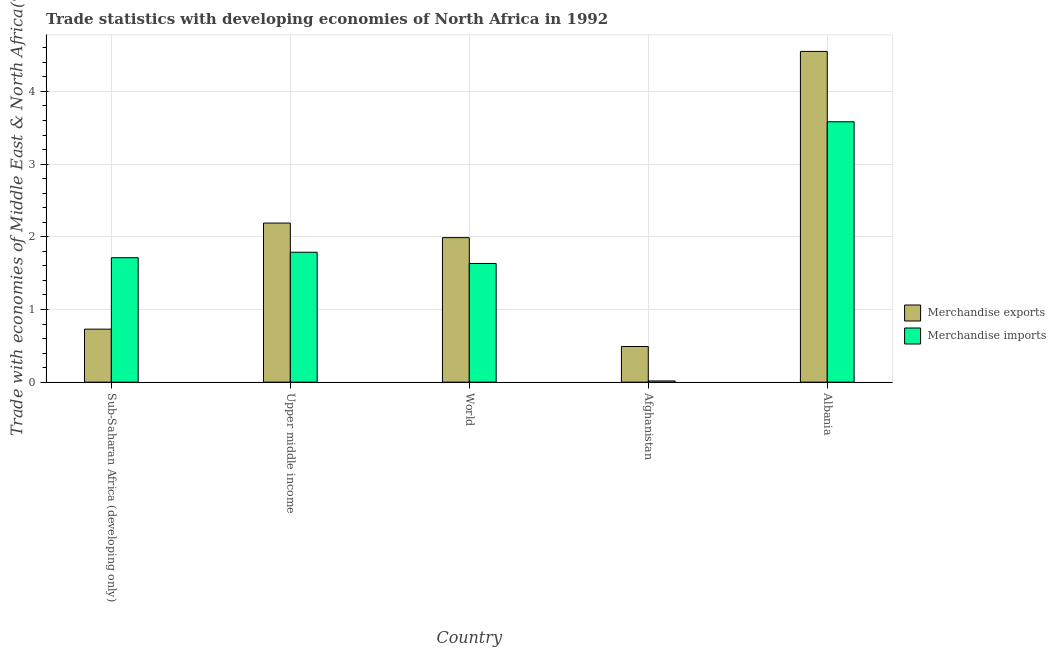How many different coloured bars are there?
Keep it short and to the point. 2. Are the number of bars on each tick of the X-axis equal?
Offer a terse response. Yes. How many bars are there on the 4th tick from the right?
Keep it short and to the point. 2. What is the label of the 4th group of bars from the left?
Offer a terse response. Afghanistan. In how many cases, is the number of bars for a given country not equal to the number of legend labels?
Offer a terse response. 0. What is the merchandise imports in Upper middle income?
Your answer should be compact. 1.79. Across all countries, what is the maximum merchandise imports?
Make the answer very short. 3.58. Across all countries, what is the minimum merchandise imports?
Provide a succinct answer. 0.02. In which country was the merchandise imports maximum?
Your answer should be very brief. Albania. In which country was the merchandise imports minimum?
Provide a short and direct response. Afghanistan. What is the total merchandise exports in the graph?
Your response must be concise. 9.95. What is the difference between the merchandise exports in Sub-Saharan Africa (developing only) and that in World?
Keep it short and to the point. -1.26. What is the difference between the merchandise exports in Afghanistan and the merchandise imports in World?
Give a very brief answer. -1.14. What is the average merchandise exports per country?
Offer a terse response. 1.99. What is the difference between the merchandise imports and merchandise exports in Sub-Saharan Africa (developing only)?
Offer a terse response. 0.98. In how many countries, is the merchandise imports greater than 4.4 %?
Ensure brevity in your answer.  0. What is the ratio of the merchandise imports in Albania to that in Sub-Saharan Africa (developing only)?
Your answer should be very brief. 2.09. Is the merchandise imports in Albania less than that in World?
Offer a very short reply. No. Is the difference between the merchandise exports in Albania and Upper middle income greater than the difference between the merchandise imports in Albania and Upper middle income?
Ensure brevity in your answer.  Yes. What is the difference between the highest and the second highest merchandise imports?
Offer a terse response. 1.8. What is the difference between the highest and the lowest merchandise exports?
Your answer should be compact. 4.06. Is the sum of the merchandise imports in Afghanistan and World greater than the maximum merchandise exports across all countries?
Provide a succinct answer. No. What does the 1st bar from the left in World represents?
Ensure brevity in your answer.  Merchandise exports. Are all the bars in the graph horizontal?
Keep it short and to the point. No. Does the graph contain any zero values?
Give a very brief answer. No. Where does the legend appear in the graph?
Offer a very short reply. Center right. How are the legend labels stacked?
Give a very brief answer. Vertical. What is the title of the graph?
Provide a succinct answer. Trade statistics with developing economies of North Africa in 1992. Does "Number of departures" appear as one of the legend labels in the graph?
Ensure brevity in your answer.  No. What is the label or title of the X-axis?
Your answer should be compact. Country. What is the label or title of the Y-axis?
Your answer should be compact. Trade with economies of Middle East & North Africa(%). What is the Trade with economies of Middle East & North Africa(%) in Merchandise exports in Sub-Saharan Africa (developing only)?
Ensure brevity in your answer.  0.73. What is the Trade with economies of Middle East & North Africa(%) of Merchandise imports in Sub-Saharan Africa (developing only)?
Offer a very short reply. 1.71. What is the Trade with economies of Middle East & North Africa(%) in Merchandise exports in Upper middle income?
Keep it short and to the point. 2.19. What is the Trade with economies of Middle East & North Africa(%) in Merchandise imports in Upper middle income?
Keep it short and to the point. 1.79. What is the Trade with economies of Middle East & North Africa(%) in Merchandise exports in World?
Provide a succinct answer. 1.99. What is the Trade with economies of Middle East & North Africa(%) in Merchandise imports in World?
Your answer should be very brief. 1.63. What is the Trade with economies of Middle East & North Africa(%) in Merchandise exports in Afghanistan?
Give a very brief answer. 0.49. What is the Trade with economies of Middle East & North Africa(%) in Merchandise imports in Afghanistan?
Your response must be concise. 0.02. What is the Trade with economies of Middle East & North Africa(%) of Merchandise exports in Albania?
Make the answer very short. 4.55. What is the Trade with economies of Middle East & North Africa(%) in Merchandise imports in Albania?
Keep it short and to the point. 3.58. Across all countries, what is the maximum Trade with economies of Middle East & North Africa(%) in Merchandise exports?
Your answer should be compact. 4.55. Across all countries, what is the maximum Trade with economies of Middle East & North Africa(%) of Merchandise imports?
Offer a terse response. 3.58. Across all countries, what is the minimum Trade with economies of Middle East & North Africa(%) of Merchandise exports?
Make the answer very short. 0.49. Across all countries, what is the minimum Trade with economies of Middle East & North Africa(%) of Merchandise imports?
Provide a succinct answer. 0.02. What is the total Trade with economies of Middle East & North Africa(%) of Merchandise exports in the graph?
Provide a short and direct response. 9.95. What is the total Trade with economies of Middle East & North Africa(%) in Merchandise imports in the graph?
Your response must be concise. 8.73. What is the difference between the Trade with economies of Middle East & North Africa(%) in Merchandise exports in Sub-Saharan Africa (developing only) and that in Upper middle income?
Your response must be concise. -1.46. What is the difference between the Trade with economies of Middle East & North Africa(%) in Merchandise imports in Sub-Saharan Africa (developing only) and that in Upper middle income?
Provide a succinct answer. -0.08. What is the difference between the Trade with economies of Middle East & North Africa(%) in Merchandise exports in Sub-Saharan Africa (developing only) and that in World?
Offer a terse response. -1.26. What is the difference between the Trade with economies of Middle East & North Africa(%) in Merchandise imports in Sub-Saharan Africa (developing only) and that in World?
Ensure brevity in your answer.  0.08. What is the difference between the Trade with economies of Middle East & North Africa(%) in Merchandise exports in Sub-Saharan Africa (developing only) and that in Afghanistan?
Offer a very short reply. 0.24. What is the difference between the Trade with economies of Middle East & North Africa(%) of Merchandise imports in Sub-Saharan Africa (developing only) and that in Afghanistan?
Offer a very short reply. 1.7. What is the difference between the Trade with economies of Middle East & North Africa(%) in Merchandise exports in Sub-Saharan Africa (developing only) and that in Albania?
Give a very brief answer. -3.82. What is the difference between the Trade with economies of Middle East & North Africa(%) of Merchandise imports in Sub-Saharan Africa (developing only) and that in Albania?
Offer a terse response. -1.87. What is the difference between the Trade with economies of Middle East & North Africa(%) in Merchandise exports in Upper middle income and that in World?
Your response must be concise. 0.2. What is the difference between the Trade with economies of Middle East & North Africa(%) of Merchandise imports in Upper middle income and that in World?
Offer a very short reply. 0.15. What is the difference between the Trade with economies of Middle East & North Africa(%) in Merchandise exports in Upper middle income and that in Afghanistan?
Offer a terse response. 1.7. What is the difference between the Trade with economies of Middle East & North Africa(%) in Merchandise imports in Upper middle income and that in Afghanistan?
Provide a succinct answer. 1.77. What is the difference between the Trade with economies of Middle East & North Africa(%) in Merchandise exports in Upper middle income and that in Albania?
Offer a terse response. -2.36. What is the difference between the Trade with economies of Middle East & North Africa(%) in Merchandise imports in Upper middle income and that in Albania?
Make the answer very short. -1.8. What is the difference between the Trade with economies of Middle East & North Africa(%) in Merchandise exports in World and that in Afghanistan?
Ensure brevity in your answer.  1.5. What is the difference between the Trade with economies of Middle East & North Africa(%) of Merchandise imports in World and that in Afghanistan?
Provide a short and direct response. 1.62. What is the difference between the Trade with economies of Middle East & North Africa(%) in Merchandise exports in World and that in Albania?
Provide a succinct answer. -2.56. What is the difference between the Trade with economies of Middle East & North Africa(%) of Merchandise imports in World and that in Albania?
Give a very brief answer. -1.95. What is the difference between the Trade with economies of Middle East & North Africa(%) of Merchandise exports in Afghanistan and that in Albania?
Offer a terse response. -4.06. What is the difference between the Trade with economies of Middle East & North Africa(%) in Merchandise imports in Afghanistan and that in Albania?
Keep it short and to the point. -3.57. What is the difference between the Trade with economies of Middle East & North Africa(%) of Merchandise exports in Sub-Saharan Africa (developing only) and the Trade with economies of Middle East & North Africa(%) of Merchandise imports in Upper middle income?
Your answer should be very brief. -1.06. What is the difference between the Trade with economies of Middle East & North Africa(%) in Merchandise exports in Sub-Saharan Africa (developing only) and the Trade with economies of Middle East & North Africa(%) in Merchandise imports in World?
Your response must be concise. -0.9. What is the difference between the Trade with economies of Middle East & North Africa(%) in Merchandise exports in Sub-Saharan Africa (developing only) and the Trade with economies of Middle East & North Africa(%) in Merchandise imports in Afghanistan?
Provide a short and direct response. 0.71. What is the difference between the Trade with economies of Middle East & North Africa(%) of Merchandise exports in Sub-Saharan Africa (developing only) and the Trade with economies of Middle East & North Africa(%) of Merchandise imports in Albania?
Ensure brevity in your answer.  -2.85. What is the difference between the Trade with economies of Middle East & North Africa(%) of Merchandise exports in Upper middle income and the Trade with economies of Middle East & North Africa(%) of Merchandise imports in World?
Keep it short and to the point. 0.56. What is the difference between the Trade with economies of Middle East & North Africa(%) of Merchandise exports in Upper middle income and the Trade with economies of Middle East & North Africa(%) of Merchandise imports in Afghanistan?
Make the answer very short. 2.17. What is the difference between the Trade with economies of Middle East & North Africa(%) of Merchandise exports in Upper middle income and the Trade with economies of Middle East & North Africa(%) of Merchandise imports in Albania?
Offer a terse response. -1.39. What is the difference between the Trade with economies of Middle East & North Africa(%) of Merchandise exports in World and the Trade with economies of Middle East & North Africa(%) of Merchandise imports in Afghanistan?
Offer a terse response. 1.97. What is the difference between the Trade with economies of Middle East & North Africa(%) of Merchandise exports in World and the Trade with economies of Middle East & North Africa(%) of Merchandise imports in Albania?
Your answer should be compact. -1.59. What is the difference between the Trade with economies of Middle East & North Africa(%) of Merchandise exports in Afghanistan and the Trade with economies of Middle East & North Africa(%) of Merchandise imports in Albania?
Offer a terse response. -3.09. What is the average Trade with economies of Middle East & North Africa(%) of Merchandise exports per country?
Make the answer very short. 1.99. What is the average Trade with economies of Middle East & North Africa(%) in Merchandise imports per country?
Make the answer very short. 1.75. What is the difference between the Trade with economies of Middle East & North Africa(%) of Merchandise exports and Trade with economies of Middle East & North Africa(%) of Merchandise imports in Sub-Saharan Africa (developing only)?
Make the answer very short. -0.98. What is the difference between the Trade with economies of Middle East & North Africa(%) of Merchandise exports and Trade with economies of Middle East & North Africa(%) of Merchandise imports in Upper middle income?
Provide a short and direct response. 0.4. What is the difference between the Trade with economies of Middle East & North Africa(%) in Merchandise exports and Trade with economies of Middle East & North Africa(%) in Merchandise imports in World?
Ensure brevity in your answer.  0.36. What is the difference between the Trade with economies of Middle East & North Africa(%) of Merchandise exports and Trade with economies of Middle East & North Africa(%) of Merchandise imports in Afghanistan?
Provide a short and direct response. 0.47. What is the difference between the Trade with economies of Middle East & North Africa(%) of Merchandise exports and Trade with economies of Middle East & North Africa(%) of Merchandise imports in Albania?
Provide a short and direct response. 0.97. What is the ratio of the Trade with economies of Middle East & North Africa(%) in Merchandise exports in Sub-Saharan Africa (developing only) to that in Upper middle income?
Give a very brief answer. 0.33. What is the ratio of the Trade with economies of Middle East & North Africa(%) in Merchandise imports in Sub-Saharan Africa (developing only) to that in Upper middle income?
Your response must be concise. 0.96. What is the ratio of the Trade with economies of Middle East & North Africa(%) in Merchandise exports in Sub-Saharan Africa (developing only) to that in World?
Offer a terse response. 0.37. What is the ratio of the Trade with economies of Middle East & North Africa(%) in Merchandise imports in Sub-Saharan Africa (developing only) to that in World?
Ensure brevity in your answer.  1.05. What is the ratio of the Trade with economies of Middle East & North Africa(%) of Merchandise exports in Sub-Saharan Africa (developing only) to that in Afghanistan?
Your answer should be compact. 1.49. What is the ratio of the Trade with economies of Middle East & North Africa(%) of Merchandise imports in Sub-Saharan Africa (developing only) to that in Afghanistan?
Your response must be concise. 103.32. What is the ratio of the Trade with economies of Middle East & North Africa(%) in Merchandise exports in Sub-Saharan Africa (developing only) to that in Albania?
Ensure brevity in your answer.  0.16. What is the ratio of the Trade with economies of Middle East & North Africa(%) of Merchandise imports in Sub-Saharan Africa (developing only) to that in Albania?
Provide a short and direct response. 0.48. What is the ratio of the Trade with economies of Middle East & North Africa(%) in Merchandise exports in Upper middle income to that in World?
Provide a succinct answer. 1.1. What is the ratio of the Trade with economies of Middle East & North Africa(%) in Merchandise imports in Upper middle income to that in World?
Provide a short and direct response. 1.09. What is the ratio of the Trade with economies of Middle East & North Africa(%) in Merchandise exports in Upper middle income to that in Afghanistan?
Offer a very short reply. 4.46. What is the ratio of the Trade with economies of Middle East & North Africa(%) of Merchandise imports in Upper middle income to that in Afghanistan?
Give a very brief answer. 107.86. What is the ratio of the Trade with economies of Middle East & North Africa(%) of Merchandise exports in Upper middle income to that in Albania?
Your answer should be very brief. 0.48. What is the ratio of the Trade with economies of Middle East & North Africa(%) of Merchandise imports in Upper middle income to that in Albania?
Make the answer very short. 0.5. What is the ratio of the Trade with economies of Middle East & North Africa(%) in Merchandise exports in World to that in Afghanistan?
Your answer should be very brief. 4.05. What is the ratio of the Trade with economies of Middle East & North Africa(%) of Merchandise imports in World to that in Afghanistan?
Provide a short and direct response. 98.54. What is the ratio of the Trade with economies of Middle East & North Africa(%) in Merchandise exports in World to that in Albania?
Your answer should be very brief. 0.44. What is the ratio of the Trade with economies of Middle East & North Africa(%) of Merchandise imports in World to that in Albania?
Ensure brevity in your answer.  0.46. What is the ratio of the Trade with economies of Middle East & North Africa(%) in Merchandise exports in Afghanistan to that in Albania?
Your response must be concise. 0.11. What is the ratio of the Trade with economies of Middle East & North Africa(%) in Merchandise imports in Afghanistan to that in Albania?
Offer a terse response. 0. What is the difference between the highest and the second highest Trade with economies of Middle East & North Africa(%) of Merchandise exports?
Keep it short and to the point. 2.36. What is the difference between the highest and the second highest Trade with economies of Middle East & North Africa(%) of Merchandise imports?
Your answer should be compact. 1.8. What is the difference between the highest and the lowest Trade with economies of Middle East & North Africa(%) in Merchandise exports?
Offer a terse response. 4.06. What is the difference between the highest and the lowest Trade with economies of Middle East & North Africa(%) in Merchandise imports?
Your answer should be compact. 3.57. 